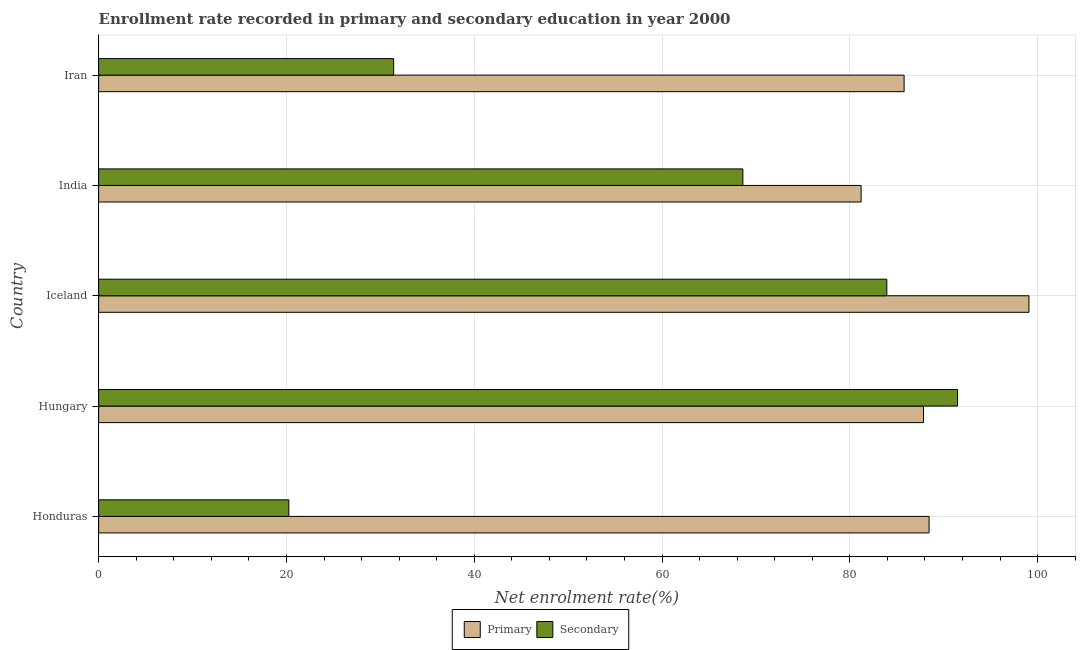Are the number of bars per tick equal to the number of legend labels?
Your answer should be very brief. Yes. Are the number of bars on each tick of the Y-axis equal?
Your answer should be compact. Yes. How many bars are there on the 5th tick from the bottom?
Offer a terse response. 2. What is the label of the 5th group of bars from the top?
Ensure brevity in your answer.  Honduras. In how many cases, is the number of bars for a given country not equal to the number of legend labels?
Offer a terse response. 0. What is the enrollment rate in primary education in Iran?
Your response must be concise. 85.78. Across all countries, what is the maximum enrollment rate in primary education?
Your answer should be very brief. 99.08. Across all countries, what is the minimum enrollment rate in primary education?
Provide a succinct answer. 81.2. In which country was the enrollment rate in primary education minimum?
Your answer should be compact. India. What is the total enrollment rate in secondary education in the graph?
Your answer should be compact. 295.69. What is the difference between the enrollment rate in secondary education in Honduras and that in India?
Your answer should be compact. -48.35. What is the difference between the enrollment rate in primary education in Hungary and the enrollment rate in secondary education in India?
Your answer should be very brief. 19.24. What is the average enrollment rate in secondary education per country?
Your response must be concise. 59.14. What is the difference between the enrollment rate in secondary education and enrollment rate in primary education in Honduras?
Provide a short and direct response. -68.18. What is the ratio of the enrollment rate in primary education in India to that in Iran?
Your answer should be compact. 0.95. Is the difference between the enrollment rate in primary education in India and Iran greater than the difference between the enrollment rate in secondary education in India and Iran?
Keep it short and to the point. No. What is the difference between the highest and the second highest enrollment rate in secondary education?
Your answer should be compact. 7.54. What is the difference between the highest and the lowest enrollment rate in primary education?
Provide a succinct answer. 17.88. In how many countries, is the enrollment rate in primary education greater than the average enrollment rate in primary education taken over all countries?
Offer a terse response. 1. What does the 1st bar from the top in India represents?
Give a very brief answer. Secondary. What does the 1st bar from the bottom in India represents?
Give a very brief answer. Primary. How many bars are there?
Offer a terse response. 10. How many countries are there in the graph?
Offer a terse response. 5. Are the values on the major ticks of X-axis written in scientific E-notation?
Provide a succinct answer. No. Does the graph contain grids?
Offer a very short reply. Yes. How are the legend labels stacked?
Make the answer very short. Horizontal. What is the title of the graph?
Provide a short and direct response. Enrollment rate recorded in primary and secondary education in year 2000. Does "Female labor force" appear as one of the legend labels in the graph?
Give a very brief answer. No. What is the label or title of the X-axis?
Your response must be concise. Net enrolment rate(%). What is the Net enrolment rate(%) in Primary in Honduras?
Your response must be concise. 88.44. What is the Net enrolment rate(%) of Secondary in Honduras?
Provide a succinct answer. 20.25. What is the Net enrolment rate(%) of Primary in Hungary?
Provide a succinct answer. 87.85. What is the Net enrolment rate(%) of Secondary in Hungary?
Offer a terse response. 91.47. What is the Net enrolment rate(%) of Primary in Iceland?
Your response must be concise. 99.08. What is the Net enrolment rate(%) of Secondary in Iceland?
Your answer should be very brief. 83.94. What is the Net enrolment rate(%) of Primary in India?
Ensure brevity in your answer.  81.2. What is the Net enrolment rate(%) in Secondary in India?
Give a very brief answer. 68.61. What is the Net enrolment rate(%) of Primary in Iran?
Make the answer very short. 85.78. What is the Net enrolment rate(%) in Secondary in Iran?
Provide a short and direct response. 31.42. Across all countries, what is the maximum Net enrolment rate(%) of Primary?
Make the answer very short. 99.08. Across all countries, what is the maximum Net enrolment rate(%) of Secondary?
Your answer should be very brief. 91.47. Across all countries, what is the minimum Net enrolment rate(%) in Primary?
Your answer should be compact. 81.2. Across all countries, what is the minimum Net enrolment rate(%) of Secondary?
Provide a succinct answer. 20.25. What is the total Net enrolment rate(%) in Primary in the graph?
Provide a short and direct response. 442.33. What is the total Net enrolment rate(%) in Secondary in the graph?
Make the answer very short. 295.69. What is the difference between the Net enrolment rate(%) in Primary in Honduras and that in Hungary?
Your response must be concise. 0.59. What is the difference between the Net enrolment rate(%) in Secondary in Honduras and that in Hungary?
Give a very brief answer. -71.22. What is the difference between the Net enrolment rate(%) in Primary in Honduras and that in Iceland?
Make the answer very short. -10.64. What is the difference between the Net enrolment rate(%) of Secondary in Honduras and that in Iceland?
Ensure brevity in your answer.  -63.68. What is the difference between the Net enrolment rate(%) of Primary in Honduras and that in India?
Your answer should be compact. 7.24. What is the difference between the Net enrolment rate(%) of Secondary in Honduras and that in India?
Give a very brief answer. -48.35. What is the difference between the Net enrolment rate(%) in Primary in Honduras and that in Iran?
Your response must be concise. 2.66. What is the difference between the Net enrolment rate(%) of Secondary in Honduras and that in Iran?
Offer a terse response. -11.16. What is the difference between the Net enrolment rate(%) of Primary in Hungary and that in Iceland?
Offer a very short reply. -11.23. What is the difference between the Net enrolment rate(%) of Secondary in Hungary and that in Iceland?
Your response must be concise. 7.54. What is the difference between the Net enrolment rate(%) of Primary in Hungary and that in India?
Your answer should be compact. 6.65. What is the difference between the Net enrolment rate(%) of Secondary in Hungary and that in India?
Give a very brief answer. 22.86. What is the difference between the Net enrolment rate(%) in Primary in Hungary and that in Iran?
Your answer should be compact. 2.07. What is the difference between the Net enrolment rate(%) in Secondary in Hungary and that in Iran?
Provide a succinct answer. 60.05. What is the difference between the Net enrolment rate(%) of Primary in Iceland and that in India?
Make the answer very short. 17.88. What is the difference between the Net enrolment rate(%) in Secondary in Iceland and that in India?
Your response must be concise. 15.33. What is the difference between the Net enrolment rate(%) of Primary in Iceland and that in Iran?
Provide a succinct answer. 13.3. What is the difference between the Net enrolment rate(%) of Secondary in Iceland and that in Iran?
Your answer should be very brief. 52.52. What is the difference between the Net enrolment rate(%) in Primary in India and that in Iran?
Keep it short and to the point. -4.58. What is the difference between the Net enrolment rate(%) in Secondary in India and that in Iran?
Make the answer very short. 37.19. What is the difference between the Net enrolment rate(%) in Primary in Honduras and the Net enrolment rate(%) in Secondary in Hungary?
Make the answer very short. -3.04. What is the difference between the Net enrolment rate(%) in Primary in Honduras and the Net enrolment rate(%) in Secondary in Iceland?
Offer a very short reply. 4.5. What is the difference between the Net enrolment rate(%) of Primary in Honduras and the Net enrolment rate(%) of Secondary in India?
Keep it short and to the point. 19.83. What is the difference between the Net enrolment rate(%) of Primary in Honduras and the Net enrolment rate(%) of Secondary in Iran?
Make the answer very short. 57.02. What is the difference between the Net enrolment rate(%) in Primary in Hungary and the Net enrolment rate(%) in Secondary in Iceland?
Provide a succinct answer. 3.91. What is the difference between the Net enrolment rate(%) of Primary in Hungary and the Net enrolment rate(%) of Secondary in India?
Make the answer very short. 19.24. What is the difference between the Net enrolment rate(%) of Primary in Hungary and the Net enrolment rate(%) of Secondary in Iran?
Offer a terse response. 56.43. What is the difference between the Net enrolment rate(%) in Primary in Iceland and the Net enrolment rate(%) in Secondary in India?
Your response must be concise. 30.47. What is the difference between the Net enrolment rate(%) of Primary in Iceland and the Net enrolment rate(%) of Secondary in Iran?
Your response must be concise. 67.66. What is the difference between the Net enrolment rate(%) in Primary in India and the Net enrolment rate(%) in Secondary in Iran?
Offer a terse response. 49.78. What is the average Net enrolment rate(%) of Primary per country?
Offer a very short reply. 88.47. What is the average Net enrolment rate(%) in Secondary per country?
Provide a succinct answer. 59.14. What is the difference between the Net enrolment rate(%) in Primary and Net enrolment rate(%) in Secondary in Honduras?
Your answer should be compact. 68.18. What is the difference between the Net enrolment rate(%) of Primary and Net enrolment rate(%) of Secondary in Hungary?
Offer a very short reply. -3.63. What is the difference between the Net enrolment rate(%) of Primary and Net enrolment rate(%) of Secondary in Iceland?
Give a very brief answer. 15.14. What is the difference between the Net enrolment rate(%) of Primary and Net enrolment rate(%) of Secondary in India?
Offer a terse response. 12.59. What is the difference between the Net enrolment rate(%) of Primary and Net enrolment rate(%) of Secondary in Iran?
Give a very brief answer. 54.36. What is the ratio of the Net enrolment rate(%) in Secondary in Honduras to that in Hungary?
Offer a very short reply. 0.22. What is the ratio of the Net enrolment rate(%) of Primary in Honduras to that in Iceland?
Keep it short and to the point. 0.89. What is the ratio of the Net enrolment rate(%) of Secondary in Honduras to that in Iceland?
Your answer should be compact. 0.24. What is the ratio of the Net enrolment rate(%) in Primary in Honduras to that in India?
Give a very brief answer. 1.09. What is the ratio of the Net enrolment rate(%) in Secondary in Honduras to that in India?
Provide a short and direct response. 0.3. What is the ratio of the Net enrolment rate(%) of Primary in Honduras to that in Iran?
Ensure brevity in your answer.  1.03. What is the ratio of the Net enrolment rate(%) in Secondary in Honduras to that in Iran?
Make the answer very short. 0.64. What is the ratio of the Net enrolment rate(%) in Primary in Hungary to that in Iceland?
Keep it short and to the point. 0.89. What is the ratio of the Net enrolment rate(%) in Secondary in Hungary to that in Iceland?
Give a very brief answer. 1.09. What is the ratio of the Net enrolment rate(%) of Primary in Hungary to that in India?
Your answer should be very brief. 1.08. What is the ratio of the Net enrolment rate(%) in Secondary in Hungary to that in India?
Provide a short and direct response. 1.33. What is the ratio of the Net enrolment rate(%) in Primary in Hungary to that in Iran?
Provide a succinct answer. 1.02. What is the ratio of the Net enrolment rate(%) in Secondary in Hungary to that in Iran?
Ensure brevity in your answer.  2.91. What is the ratio of the Net enrolment rate(%) of Primary in Iceland to that in India?
Keep it short and to the point. 1.22. What is the ratio of the Net enrolment rate(%) of Secondary in Iceland to that in India?
Give a very brief answer. 1.22. What is the ratio of the Net enrolment rate(%) of Primary in Iceland to that in Iran?
Offer a very short reply. 1.16. What is the ratio of the Net enrolment rate(%) in Secondary in Iceland to that in Iran?
Provide a short and direct response. 2.67. What is the ratio of the Net enrolment rate(%) in Primary in India to that in Iran?
Offer a very short reply. 0.95. What is the ratio of the Net enrolment rate(%) in Secondary in India to that in Iran?
Your answer should be compact. 2.18. What is the difference between the highest and the second highest Net enrolment rate(%) of Primary?
Make the answer very short. 10.64. What is the difference between the highest and the second highest Net enrolment rate(%) in Secondary?
Ensure brevity in your answer.  7.54. What is the difference between the highest and the lowest Net enrolment rate(%) of Primary?
Keep it short and to the point. 17.88. What is the difference between the highest and the lowest Net enrolment rate(%) in Secondary?
Provide a short and direct response. 71.22. 